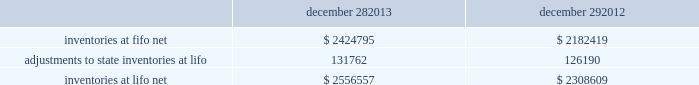Advance auto parts , inc .
And subsidiaries notes to the consolidated financial statements december 28 , 2013 , december 29 , 2012 and december 31 , 2011 ( in thousands , except per share data ) in july 2012 , the fasb issued asu no .
2012-02 201cintangible-goodwill and other 2013 testing indefinite-lived intangible assets for impairment . 201d asu 2012-02 modifies the requirement to test intangible assets that are not subject to amortization based on events or changes in circumstances that might indicate that the asset is impaired now requiring the test only if it is more likely than not that the asset is impaired .
Furthermore , asu 2012-02 provides entities the option of performing a qualitative assessment to determine if it is more likely than not that the fair value of an intangible asset is less than the carrying amount as a basis for determining whether it is necessary to perform a quantitative impairment test .
Asu 2012-02 is effective for fiscal years beginning after september 15 , 2012 and early adoption is permitted .
The adoption of asu 2012-02 had no impact on the company 2019s consolidated financial condition , results of operations or cash flows .
Inventories , net : merchandise inventory the company used the lifo method of accounting for approximately 95% ( 95 % ) of inventories at both december 28 , 2013 and december 29 , 2012 .
Under lifo , the company 2019s cost of sales reflects the costs of the most recently purchased inventories , while the inventory carrying balance represents the costs for inventories purchased in fiscal 2013 and prior years .
The company recorded a reduction to cost of sales of $ 5572 and $ 24087 in fiscal 2013 and fiscal 2012 , respectively .
The company 2019s overall costs to acquire inventory for the same or similar products have generally decreased historically as the company has been able to leverage its continued growth , execution of merchandise strategies and realization of supply chain efficiencies .
In fiscal 2011 , the company recorded an increase to cost of sales of $ 24708 due to an increase in supply chain costs and inflationary pressures affecting certain product categories .
Product cores the remaining inventories are comprised of product cores , the non-consumable portion of certain parts and batteries , which are valued under the first-in , first-out ( 201cfifo 201d ) method .
Product cores are included as part of the company 2019s merchandise costs and are either passed on to the customer or returned to the vendor .
Because product cores are not subject to frequent cost changes like the company 2019s other merchandise inventory , there is no material difference when applying either the lifo or fifo valuation method .
Inventory overhead costs purchasing and warehousing costs included in inventory as of december 28 , 2013 and december 29 , 2012 , were $ 161519 and $ 134258 , respectively .
Inventory balance and inventory reserves inventory balances at the end of fiscal 2013 and 2012 were as follows : december 28 , december 29 .
Inventory quantities are tracked through a perpetual inventory system .
The company completes physical inventories and other targeted inventory counts in its store locations to ensure the accuracy of the perpetual inventory quantities of both merchandise and core inventory in these locations .
In its distribution centers and pdq aes , the company uses a cycle counting program to ensure the accuracy of the perpetual inventory quantities of both merchandise and product core inventory .
Reserves for estimated shrink are established based on the results of physical inventories conducted by the company with the assistance of an independent third party in substantially all of the company 2019s stores over the course of the year , other targeted inventory counts in its stores , results from recent cycle counts in its distribution facilities and historical and current loss trends. .
What is the percentage increase in inventories balance due to the adoption of lifo in 2012? 
Computations: (126190 / 2182419)
Answer: 0.05782. 